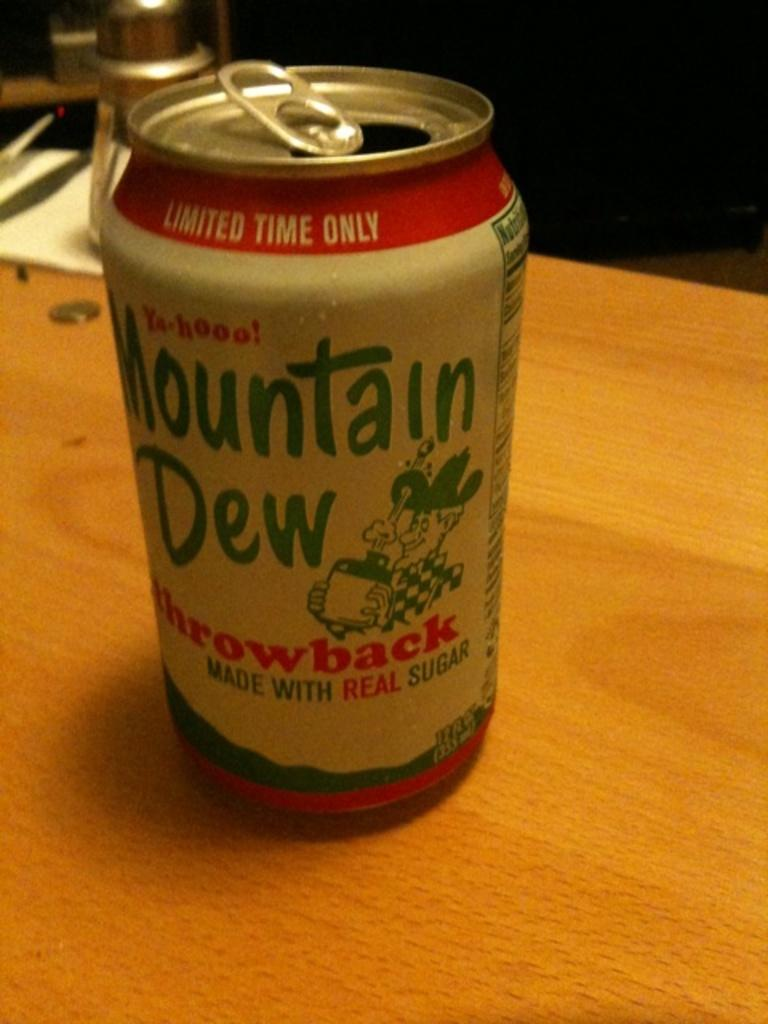<image>
Write a terse but informative summary of the picture. a mountain dew that is from a can 